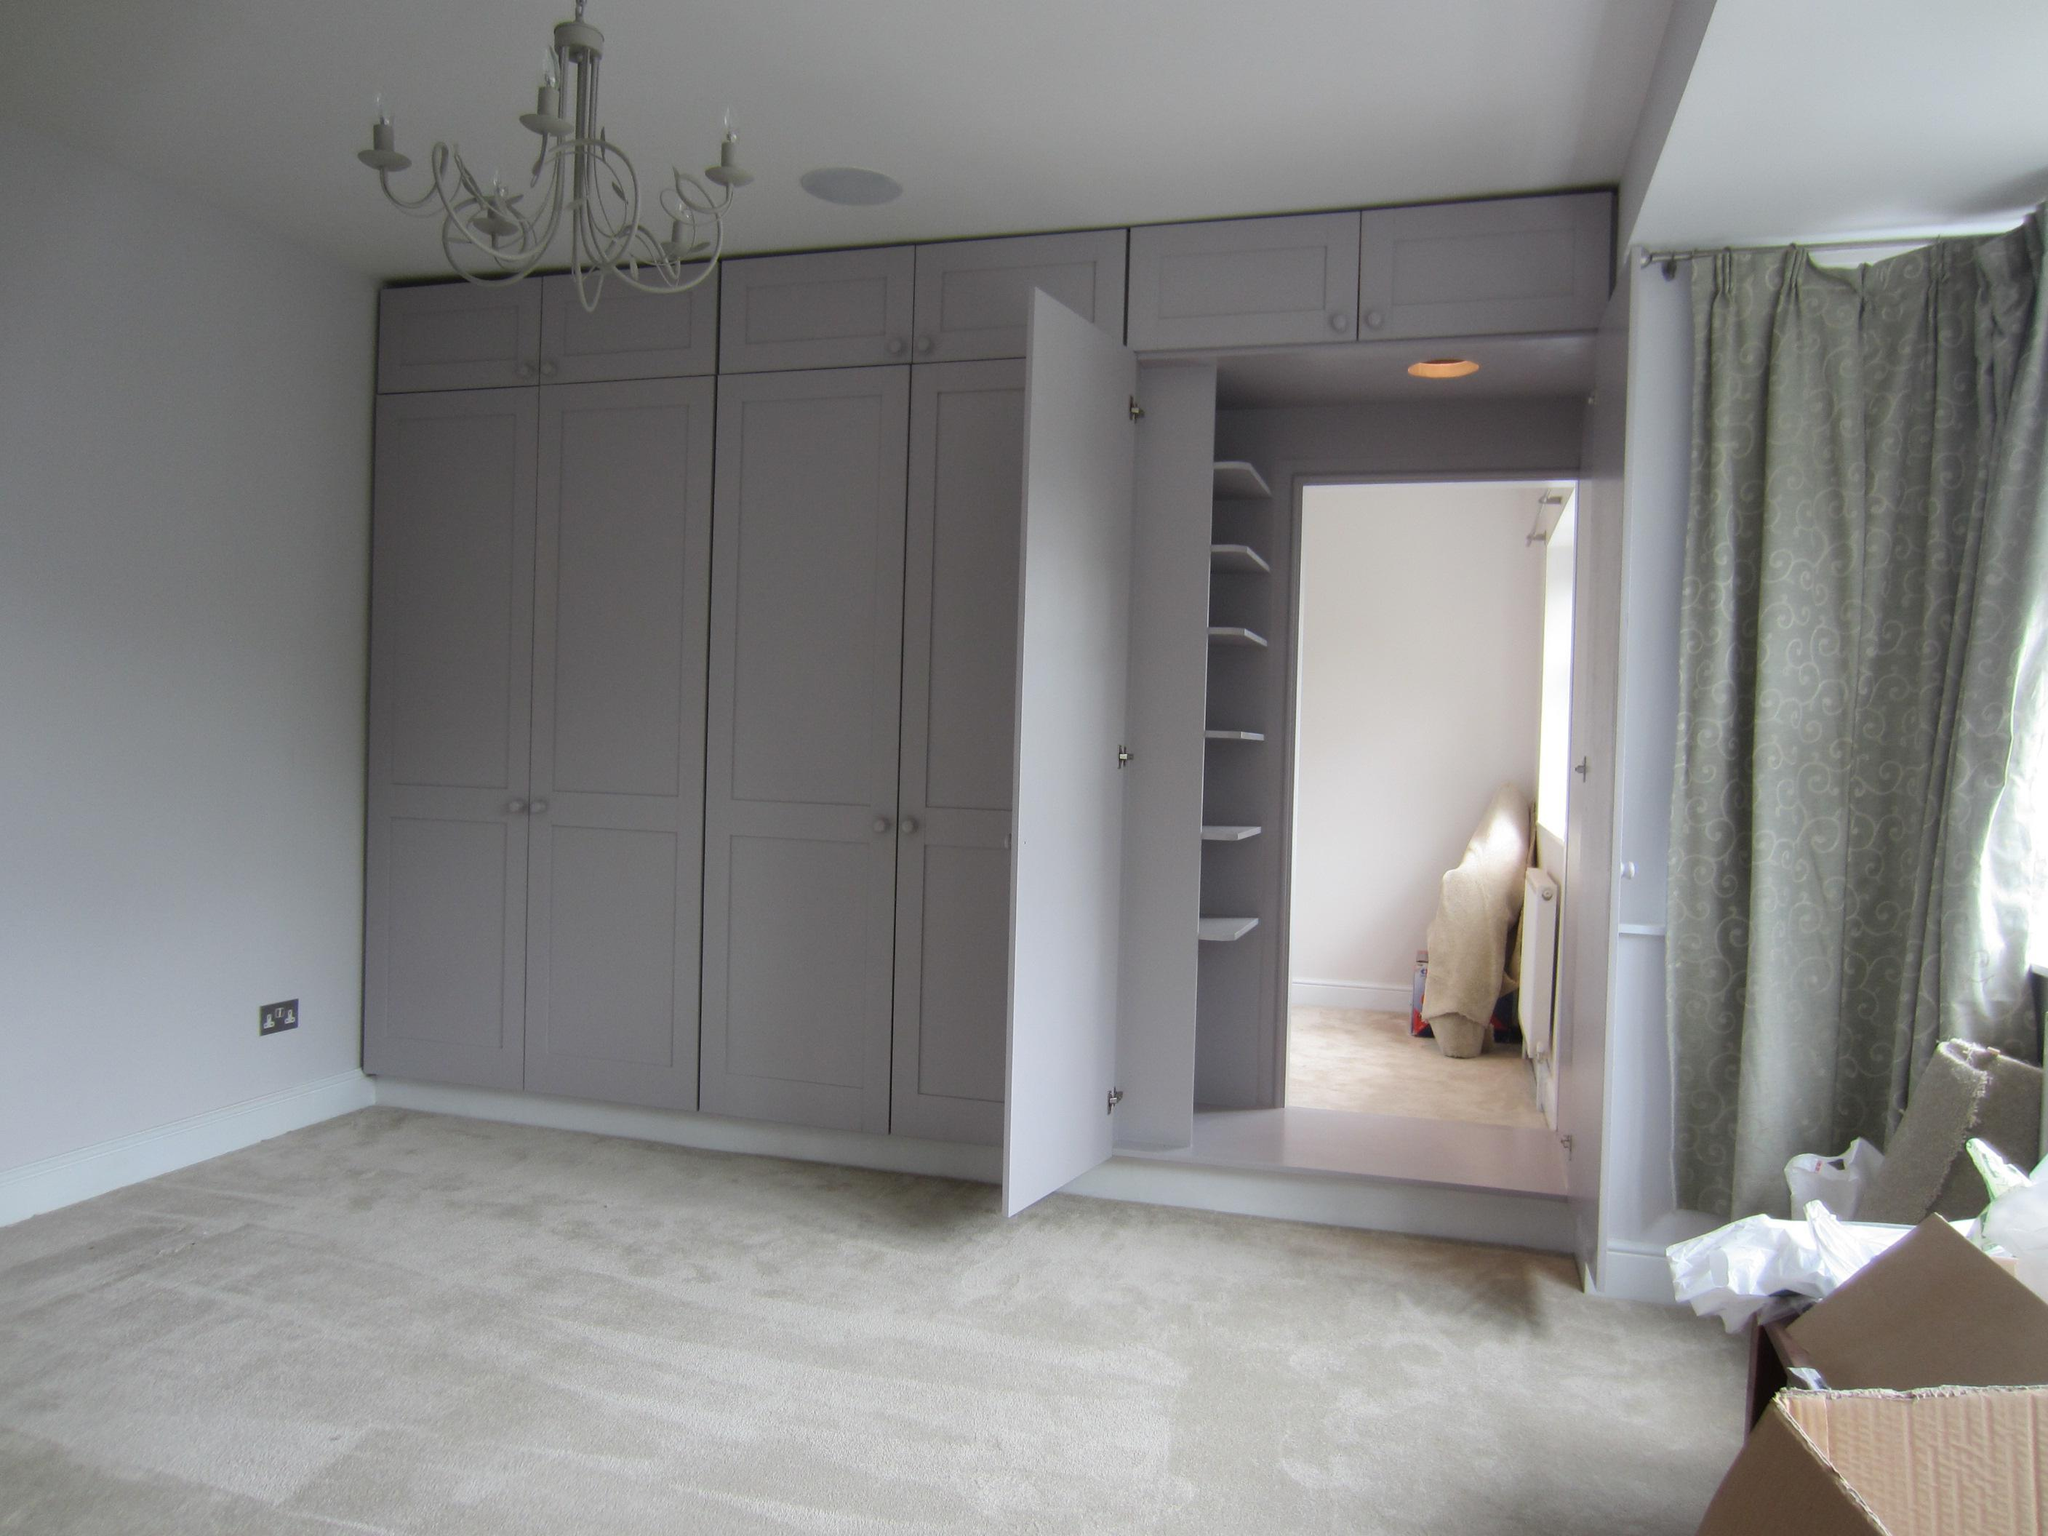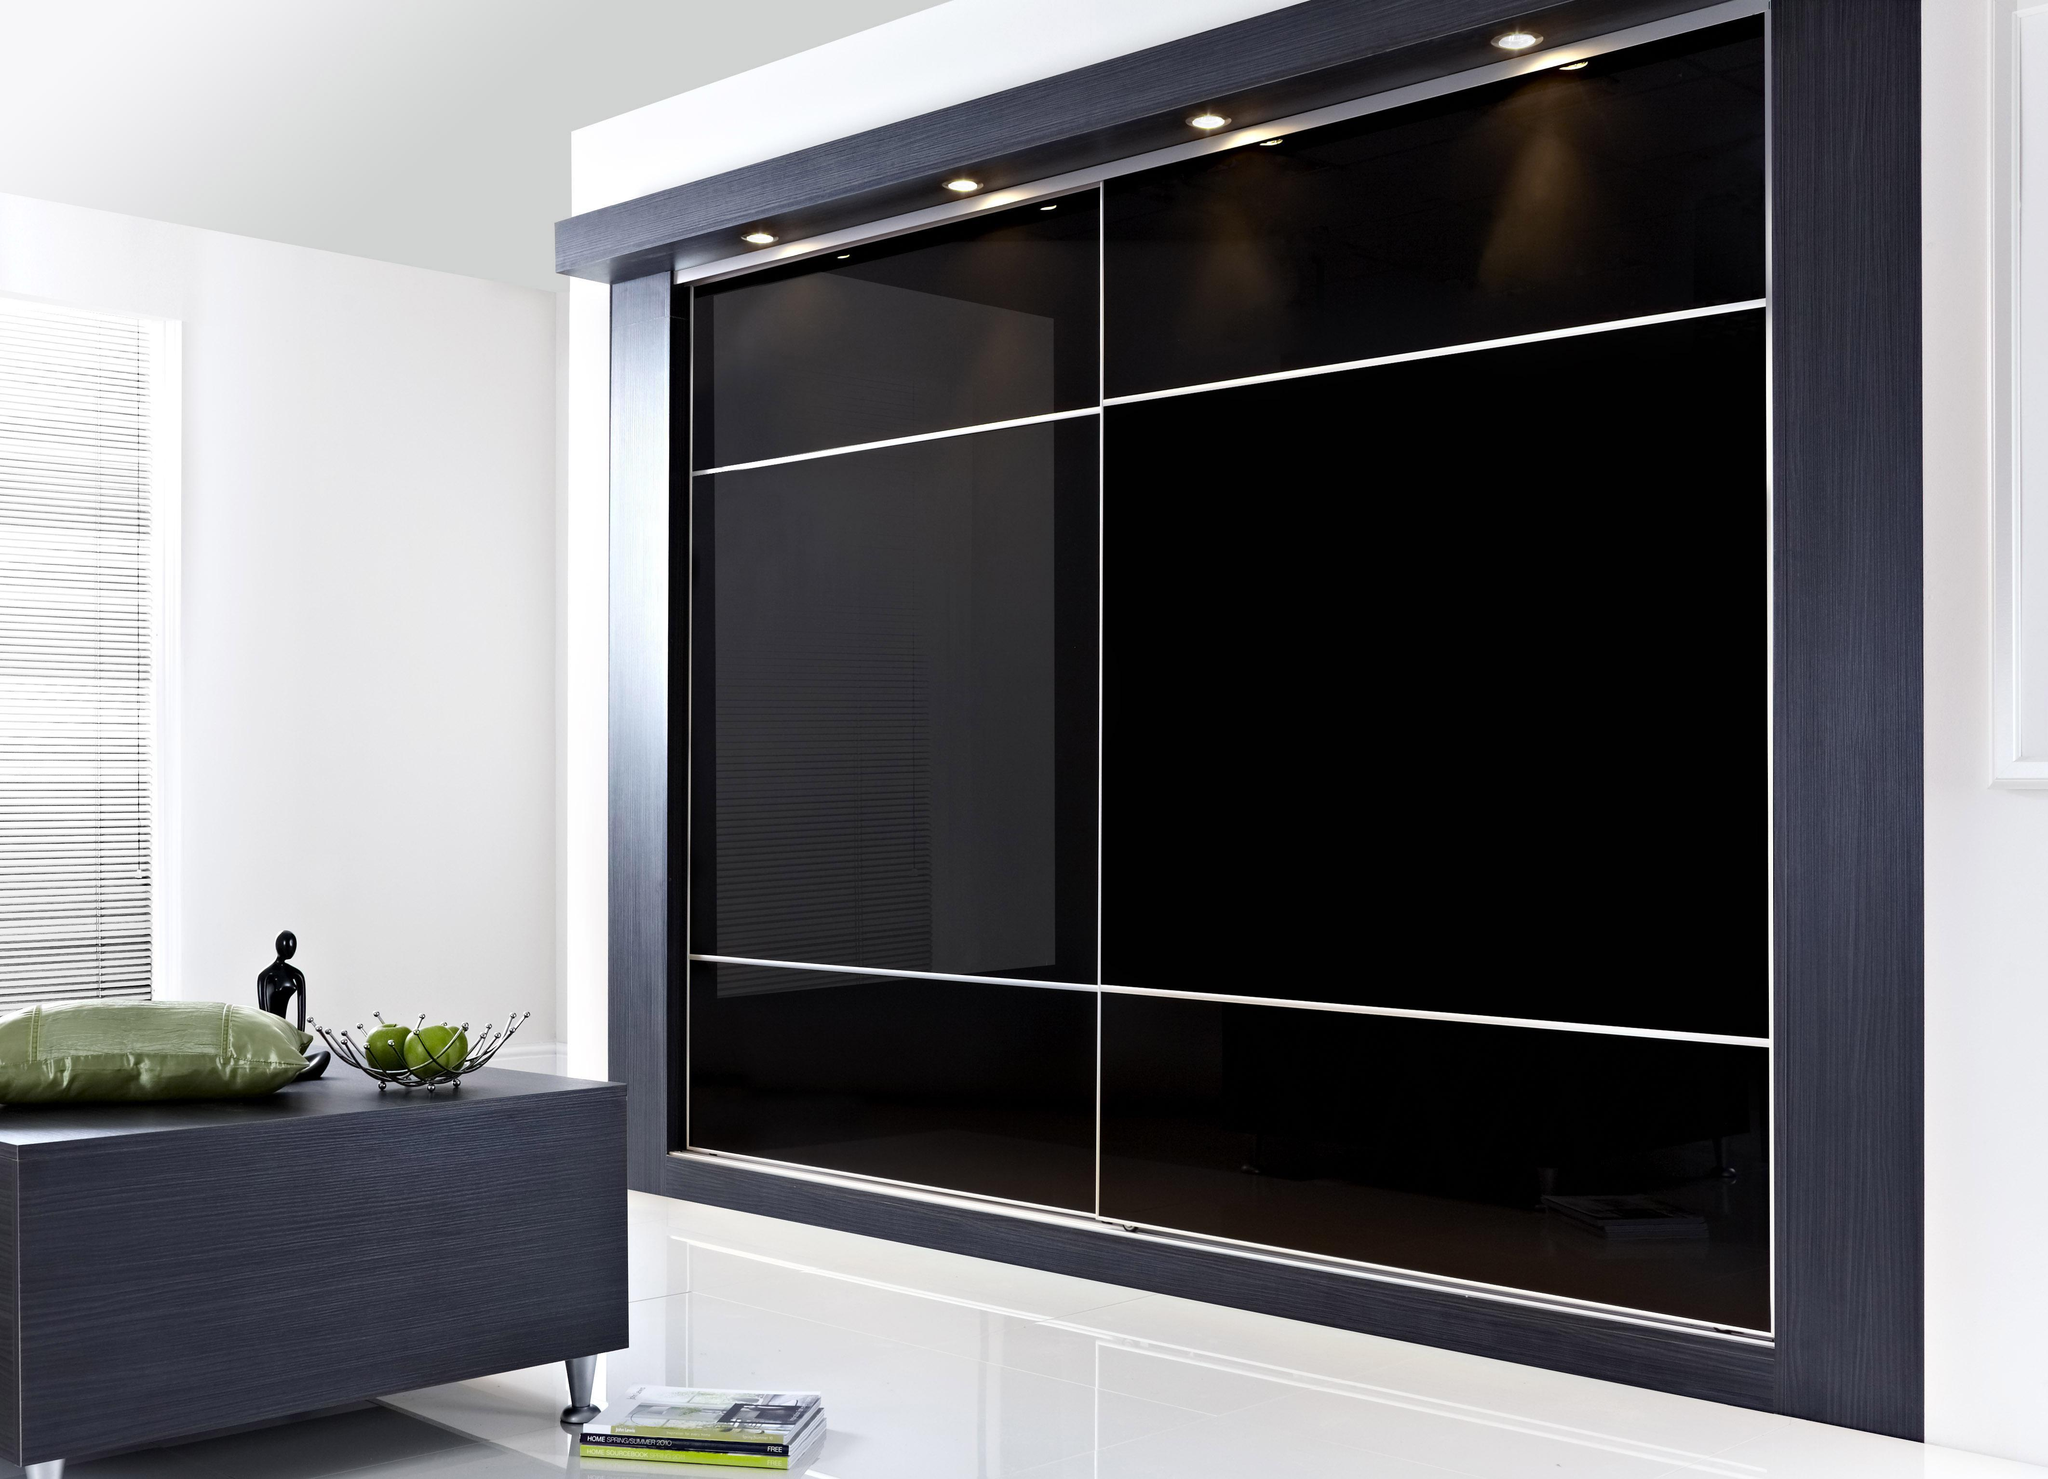The first image is the image on the left, the second image is the image on the right. For the images shown, is this caption "A mirror is reflecting into the room." true? Answer yes or no. No. The first image is the image on the left, the second image is the image on the right. Evaluate the accuracy of this statement regarding the images: "An image shows a wardrobe with partly open doors revealing items and shelves inside.". Is it true? Answer yes or no. No. 